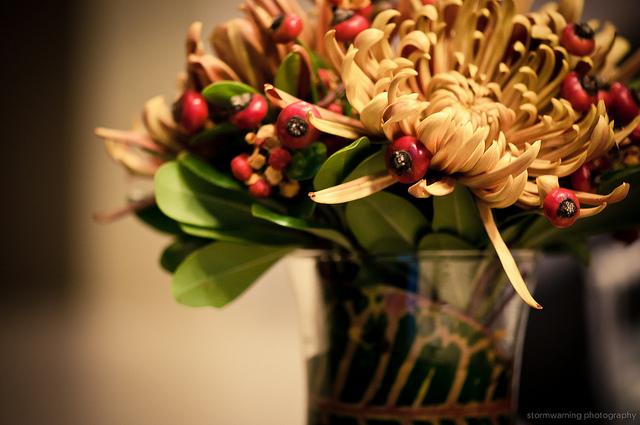Is there water in the vase?
Be succinct. Yes. Do flowers like that grow in your garden?
Answer briefly. No. Do the flowers smell good?
Be succinct. Yes. 